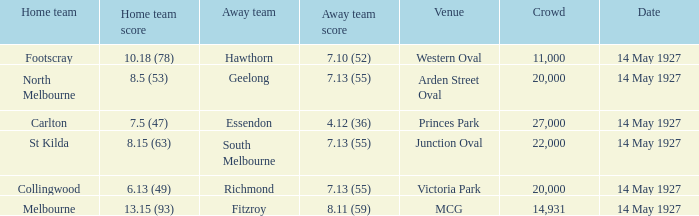Would you mind parsing the complete table? {'header': ['Home team', 'Home team score', 'Away team', 'Away team score', 'Venue', 'Crowd', 'Date'], 'rows': [['Footscray', '10.18 (78)', 'Hawthorn', '7.10 (52)', 'Western Oval', '11,000', '14 May 1927'], ['North Melbourne', '8.5 (53)', 'Geelong', '7.13 (55)', 'Arden Street Oval', '20,000', '14 May 1927'], ['Carlton', '7.5 (47)', 'Essendon', '4.12 (36)', 'Princes Park', '27,000', '14 May 1927'], ['St Kilda', '8.15 (63)', 'South Melbourne', '7.13 (55)', 'Junction Oval', '22,000', '14 May 1927'], ['Collingwood', '6.13 (49)', 'Richmond', '7.13 (55)', 'Victoria Park', '20,000', '14 May 1927'], ['Melbourne', '13.15 (93)', 'Fitzroy', '8.11 (59)', 'MCG', '14,931', '14 May 1927']]} Which away team had a score of 4.12 (36)? Essendon. 